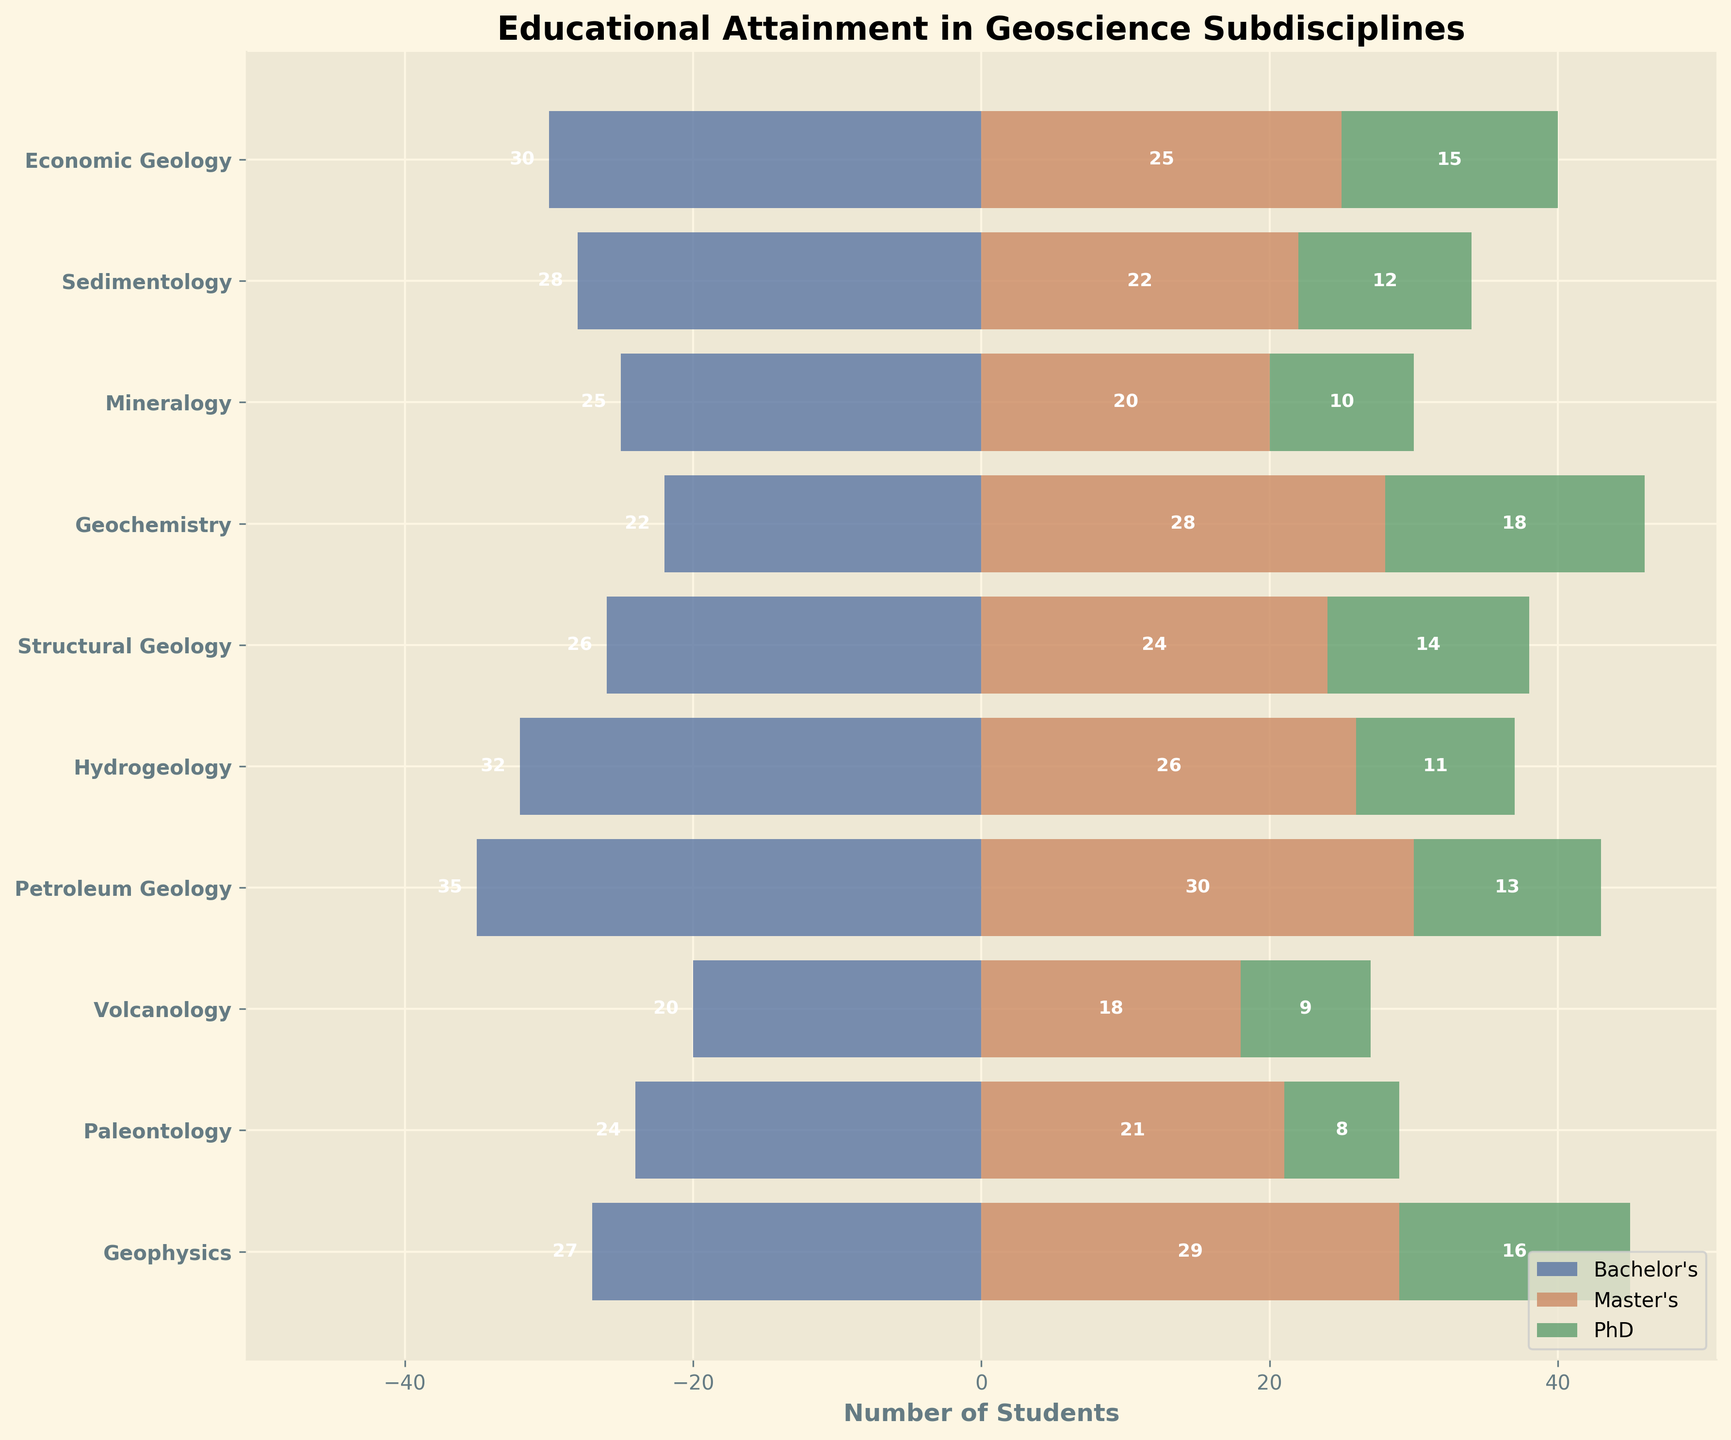what is the title of the plot? The title is often positioned at the top of the plot. In this case, the title is "Educational Attainment in Geoscience Subdisciplines."
Answer: Educational Attainment in Geoscience Subdisciplines what does the x-axis represent? The x-axis represents the number of students in each educational attainment level. The Bachelor's values are negative on the left, Master's and PhD values are positive on the right.
Answer: Number of Students which subdiscipline has the highest number of Bachelor's degree holders? By examining the bars on the left, we can see that Petroleum Geology has the longest bar with 35 Bachelor's degree holders.
Answer: Petroleum Geology how many PhD holders are there in Hydrogeology? The green bar corresponding to PhD degree for Hydrogeology is labeled with the number 11.
Answer: 11 which subdiscipline has the smallest number of students in total (sum of Bachelor's, Master's, and PhD)? Calculate the total for each subdiscipline by adding the values from all three educational levels: 
Economic Geology: 30+25+15=70 
Sedimentology: 28+22+12=62 
Mineralogy: 25+20+10=55 
Geochemistry: 22+28+18=68 
Structural Geology: 26+24+14=64 
Hydrogeology: 32+26+11=69 
Petroleum Geology: 35+30+13=78 
Volcanology: 20+18+9=47 
Paleontology: 24+21+8=53 
Geophysics: 27+29+16=72 
Volcanology has the smallest total number of students, which is 47.
Answer: Volcanology among Bachelor’s and Master's degree holders, which subdiscipline shows the highest combined number? Combine Bachelor's and Master's values and identify the highest: 
Economic Geology: 30+25=55 
Sedimentology: 28+22=50 
Mineralogy: 25+20=45 
Geochemistry: 22+28=50 
Structural Geology: 26+24=50 
Hydrogeology: 32+26=58 
Petroleum Geology: 35+30=65 
Volcanology: 20+18=38 
Paleontology: 24+21=45 
Geophysics: 27+29=56 
Petroleum Geology has the highest combined number of Bachelor's and Master's degree holders, which totals 65.
Answer: Petroleum Geology which subdiscipline has more Master's degree holders than Bachelor's degree holders? Comparing the lengths of the red and blue bars, Geochemistry and Geophysics are the only subdisciplines with more Master's (28 and 29) than Bachelor's (22 and 27).
Answer: Geochemistry, Geophysics what is the difference in the number of PhD holders between Geophysics and Volcanology? Subtract the number of Volcanology PhD holders (9) from the number of Geophysics PhD holders (16): 16 - 9 = 7.
Answer: 7 which educational level shows the highest value across all subdisciplines? By comparing all the individual bars' maxima, the Petroleum Geology Bachelor's bar (35) is the longest.
Answer: Bachelor's in Petroleum Geology do any subdisciplines have equal numbers of Bachelor's and Master's degree holders? Compare the blue and red bars for all subdisciplines; none have equal lengths for Bachelor's and Master's degree holders.
Answer: No 